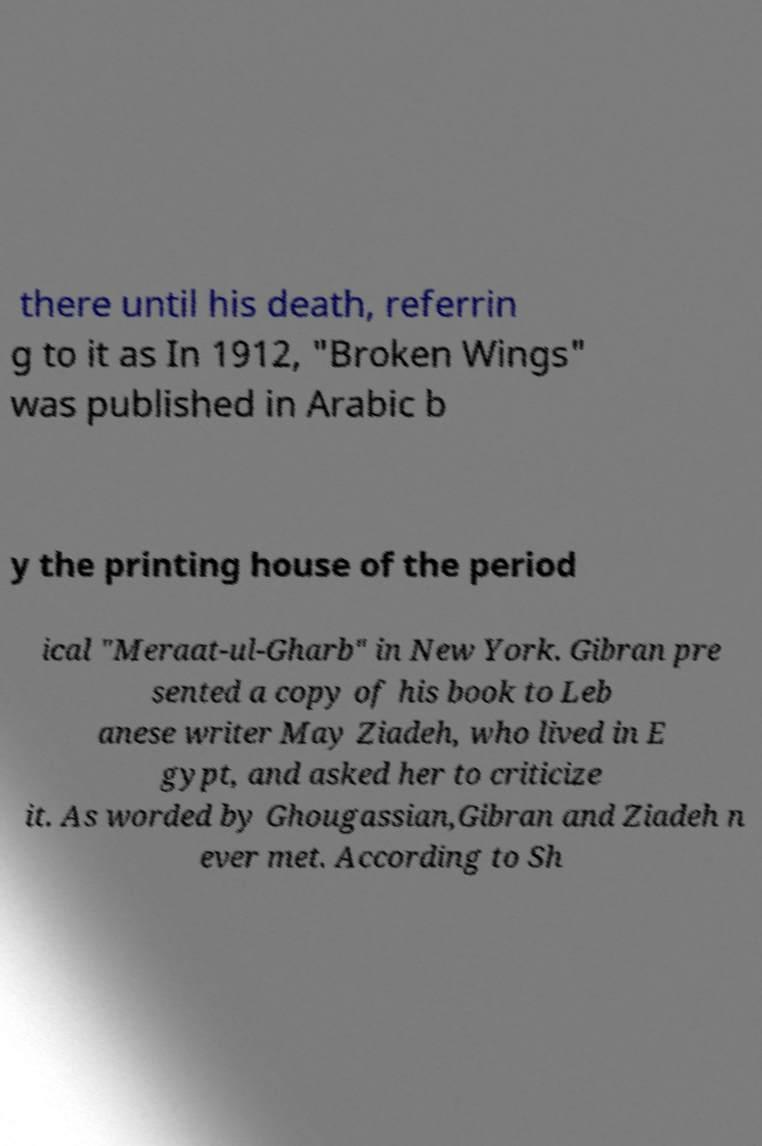Please read and relay the text visible in this image. What does it say? there until his death, referrin g to it as In 1912, "Broken Wings" was published in Arabic b y the printing house of the period ical "Meraat-ul-Gharb" in New York. Gibran pre sented a copy of his book to Leb anese writer May Ziadeh, who lived in E gypt, and asked her to criticize it. As worded by Ghougassian,Gibran and Ziadeh n ever met. According to Sh 